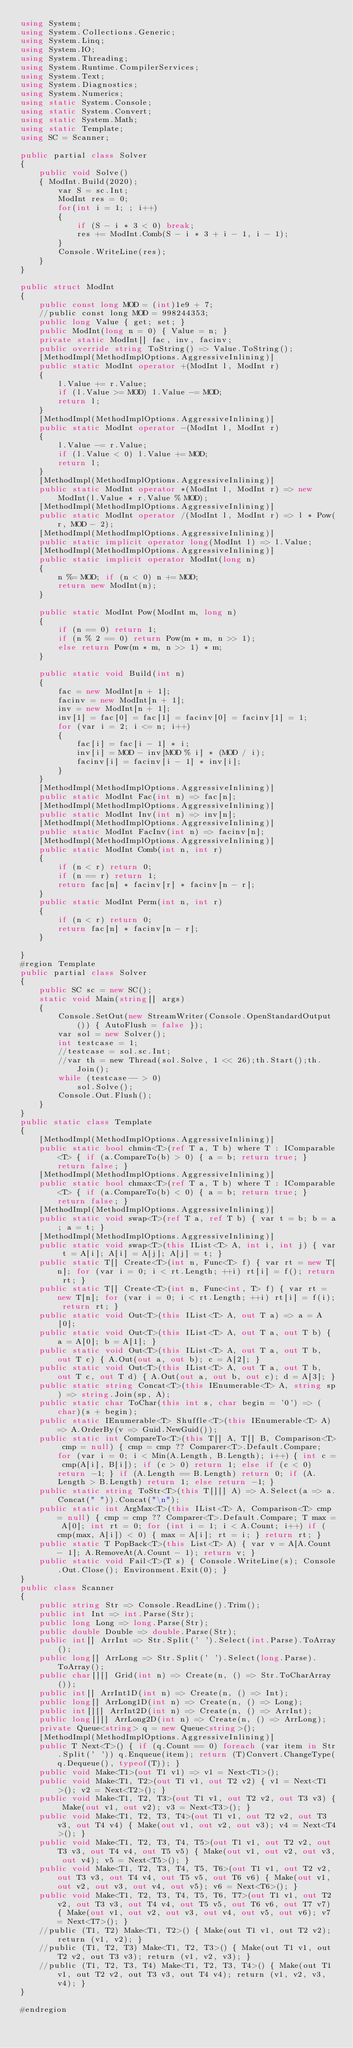Convert code to text. <code><loc_0><loc_0><loc_500><loc_500><_C#_>using System;
using System.Collections.Generic;
using System.Linq;
using System.IO;
using System.Threading;
using System.Runtime.CompilerServices;
using System.Text;
using System.Diagnostics;
using System.Numerics;
using static System.Console;
using static System.Convert;
using static System.Math;
using static Template;
using SC = Scanner;

public partial class Solver
{
    public void Solve()
    { ModInt.Build(2020);
        var S = sc.Int;
        ModInt res = 0;
        for(int i = 1; ; i++)
        {
            if (S - i * 3 < 0) break;
            res += ModInt.Comb(S - i * 3 + i - 1, i - 1);
        }
        Console.WriteLine(res);
    }
}

public struct ModInt
{
    public const long MOD = (int)1e9 + 7;
    //public const long MOD = 998244353;
    public long Value { get; set; }
    public ModInt(long n = 0) { Value = n; }
    private static ModInt[] fac, inv, facinv;
    public override string ToString() => Value.ToString();
    [MethodImpl(MethodImplOptions.AggressiveInlining)]
    public static ModInt operator +(ModInt l, ModInt r)
    {
        l.Value += r.Value;
        if (l.Value >= MOD) l.Value -= MOD;
        return l;
    }
    [MethodImpl(MethodImplOptions.AggressiveInlining)]
    public static ModInt operator -(ModInt l, ModInt r)
    {
        l.Value -= r.Value;
        if (l.Value < 0) l.Value += MOD;
        return l;
    }
    [MethodImpl(MethodImplOptions.AggressiveInlining)]
    public static ModInt operator *(ModInt l, ModInt r) => new ModInt(l.Value * r.Value % MOD);
    [MethodImpl(MethodImplOptions.AggressiveInlining)]
    public static ModInt operator /(ModInt l, ModInt r) => l * Pow(r, MOD - 2);
    [MethodImpl(MethodImplOptions.AggressiveInlining)]
    public static implicit operator long(ModInt l) => l.Value;
    [MethodImpl(MethodImplOptions.AggressiveInlining)]
    public static implicit operator ModInt(long n)
    {
        n %= MOD; if (n < 0) n += MOD;
        return new ModInt(n);
    }

    public static ModInt Pow(ModInt m, long n)
    {
        if (n == 0) return 1;
        if (n % 2 == 0) return Pow(m * m, n >> 1);
        else return Pow(m * m, n >> 1) * m;
    }

    public static void Build(int n)
    {
        fac = new ModInt[n + 1];
        facinv = new ModInt[n + 1];
        inv = new ModInt[n + 1];
        inv[1] = fac[0] = fac[1] = facinv[0] = facinv[1] = 1;
        for (var i = 2; i <= n; i++)
        {
            fac[i] = fac[i - 1] * i;
            inv[i] = MOD - inv[MOD % i] * (MOD / i);
            facinv[i] = facinv[i - 1] * inv[i];
        }
    }
    [MethodImpl(MethodImplOptions.AggressiveInlining)]
    public static ModInt Fac(int n) => fac[n];
    [MethodImpl(MethodImplOptions.AggressiveInlining)]
    public static ModInt Inv(int n) => inv[n];
    [MethodImpl(MethodImplOptions.AggressiveInlining)]
    public static ModInt FacInv(int n) => facinv[n];
    [MethodImpl(MethodImplOptions.AggressiveInlining)]
    public static ModInt Comb(int n, int r)
    {
        if (n < r) return 0;
        if (n == r) return 1;
        return fac[n] * facinv[r] * facinv[n - r];
    }
    public static ModInt Perm(int n, int r)
    {
        if (n < r) return 0;
        return fac[n] * facinv[n - r];
    }

}
#region Template
public partial class Solver
{
    public SC sc = new SC();
    static void Main(string[] args)
    {
        Console.SetOut(new StreamWriter(Console.OpenStandardOutput()) { AutoFlush = false });
        var sol = new Solver();
        int testcase = 1;
        //testcase = sol.sc.Int;
        //var th = new Thread(sol.Solve, 1 << 26);th.Start();th.Join();
        while (testcase-- > 0)
            sol.Solve();
        Console.Out.Flush();
    }
}
public static class Template
{
    [MethodImpl(MethodImplOptions.AggressiveInlining)]
    public static bool chmin<T>(ref T a, T b) where T : IComparable<T> { if (a.CompareTo(b) > 0) { a = b; return true; } return false; }
    [MethodImpl(MethodImplOptions.AggressiveInlining)]
    public static bool chmax<T>(ref T a, T b) where T : IComparable<T> { if (a.CompareTo(b) < 0) { a = b; return true; } return false; }
    [MethodImpl(MethodImplOptions.AggressiveInlining)]
    public static void swap<T>(ref T a, ref T b) { var t = b; b = a; a = t; }
    [MethodImpl(MethodImplOptions.AggressiveInlining)]
    public static void swap<T>(this IList<T> A, int i, int j) { var t = A[i]; A[i] = A[j]; A[j] = t; }
    public static T[] Create<T>(int n, Func<T> f) { var rt = new T[n]; for (var i = 0; i < rt.Length; ++i) rt[i] = f(); return rt; }
    public static T[] Create<T>(int n, Func<int, T> f) { var rt = new T[n]; for (var i = 0; i < rt.Length; ++i) rt[i] = f(i); return rt; }
    public static void Out<T>(this IList<T> A, out T a) => a = A[0];
    public static void Out<T>(this IList<T> A, out T a, out T b) { a = A[0]; b = A[1]; }
    public static void Out<T>(this IList<T> A, out T a, out T b, out T c) { A.Out(out a, out b); c = A[2]; }
    public static void Out<T>(this IList<T> A, out T a, out T b, out T c, out T d) { A.Out(out a, out b, out c); d = A[3]; }
    public static string Concat<T>(this IEnumerable<T> A, string sp) => string.Join(sp, A);
    public static char ToChar(this int s, char begin = '0') => (char)(s + begin);
    public static IEnumerable<T> Shuffle<T>(this IEnumerable<T> A) => A.OrderBy(v => Guid.NewGuid());
    public static int CompareTo<T>(this T[] A, T[] B, Comparison<T> cmp = null) { cmp = cmp ?? Comparer<T>.Default.Compare; for (var i = 0; i < Min(A.Length, B.Length); i++) { int c = cmp(A[i], B[i]); if (c > 0) return 1; else if (c < 0) return -1; } if (A.Length == B.Length) return 0; if (A.Length > B.Length) return 1; else return -1; }
    public static string ToStr<T>(this T[][] A) => A.Select(a => a.Concat(" ")).Concat("\n");
    public static int ArgMax<T>(this IList<T> A, Comparison<T> cmp = null) { cmp = cmp ?? Comparer<T>.Default.Compare; T max = A[0]; int rt = 0; for (int i = 1; i < A.Count; i++) if (cmp(max, A[i]) < 0) { max = A[i]; rt = i; } return rt; }
    public static T PopBack<T>(this List<T> A) { var v = A[A.Count - 1]; A.RemoveAt(A.Count - 1); return v; }
    public static void Fail<T>(T s) { Console.WriteLine(s); Console.Out.Close(); Environment.Exit(0); }
}
public class Scanner
{
    public string Str => Console.ReadLine().Trim();
    public int Int => int.Parse(Str);
    public long Long => long.Parse(Str);
    public double Double => double.Parse(Str);
    public int[] ArrInt => Str.Split(' ').Select(int.Parse).ToArray();
    public long[] ArrLong => Str.Split(' ').Select(long.Parse).ToArray();
    public char[][] Grid(int n) => Create(n, () => Str.ToCharArray());
    public int[] ArrInt1D(int n) => Create(n, () => Int);
    public long[] ArrLong1D(int n) => Create(n, () => Long);
    public int[][] ArrInt2D(int n) => Create(n, () => ArrInt);
    public long[][] ArrLong2D(int n) => Create(n, () => ArrLong);
    private Queue<string> q = new Queue<string>();
    [MethodImpl(MethodImplOptions.AggressiveInlining)]
    public T Next<T>() { if (q.Count == 0) foreach (var item in Str.Split(' ')) q.Enqueue(item); return (T)Convert.ChangeType(q.Dequeue(), typeof(T)); }
    public void Make<T1>(out T1 v1) => v1 = Next<T1>();
    public void Make<T1, T2>(out T1 v1, out T2 v2) { v1 = Next<T1>(); v2 = Next<T2>(); }
    public void Make<T1, T2, T3>(out T1 v1, out T2 v2, out T3 v3) { Make(out v1, out v2); v3 = Next<T3>(); }
    public void Make<T1, T2, T3, T4>(out T1 v1, out T2 v2, out T3 v3, out T4 v4) { Make(out v1, out v2, out v3); v4 = Next<T4>(); }
    public void Make<T1, T2, T3, T4, T5>(out T1 v1, out T2 v2, out T3 v3, out T4 v4, out T5 v5) { Make(out v1, out v2, out v3, out v4); v5 = Next<T5>(); }
    public void Make<T1, T2, T3, T4, T5, T6>(out T1 v1, out T2 v2, out T3 v3, out T4 v4, out T5 v5, out T6 v6) { Make(out v1, out v2, out v3, out v4, out v5); v6 = Next<T6>(); }
    public void Make<T1, T2, T3, T4, T5, T6, T7>(out T1 v1, out T2 v2, out T3 v3, out T4 v4, out T5 v5, out T6 v6, out T7 v7) { Make(out v1, out v2, out v3, out v4, out v5, out v6); v7 = Next<T7>(); }
    //public (T1, T2) Make<T1, T2>() { Make(out T1 v1, out T2 v2); return (v1, v2); }
    //public (T1, T2, T3) Make<T1, T2, T3>() { Make(out T1 v1, out T2 v2, out T3 v3); return (v1, v2, v3); }
    //public (T1, T2, T3, T4) Make<T1, T2, T3, T4>() { Make(out T1 v1, out T2 v2, out T3 v3, out T4 v4); return (v1, v2, v3, v4); }
}

#endregion
</code> 